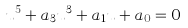Convert formula to latex. <formula><loc_0><loc_0><loc_500><loc_500>u ^ { 5 } + a _ { 3 } u ^ { 3 } + a _ { 1 } u + a _ { 0 } = 0</formula> 